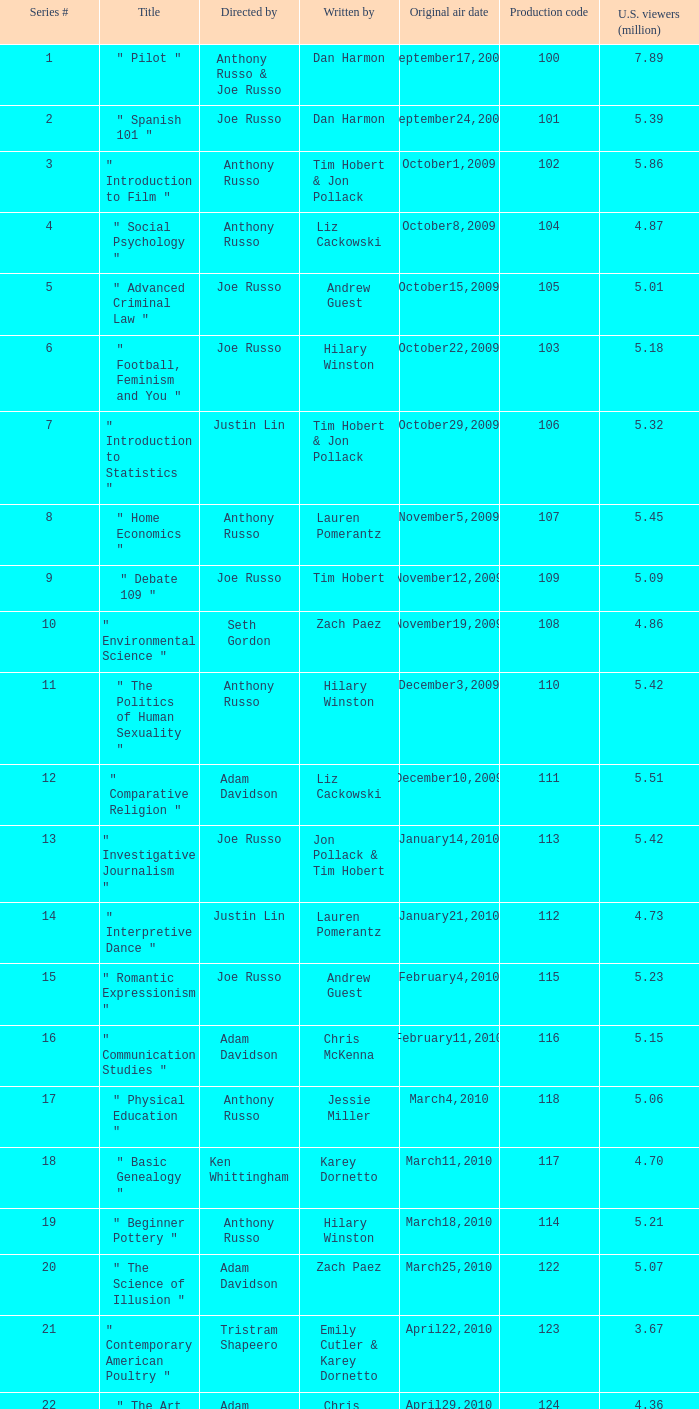What is the highest series # directed by ken whittingham? 18.0. 